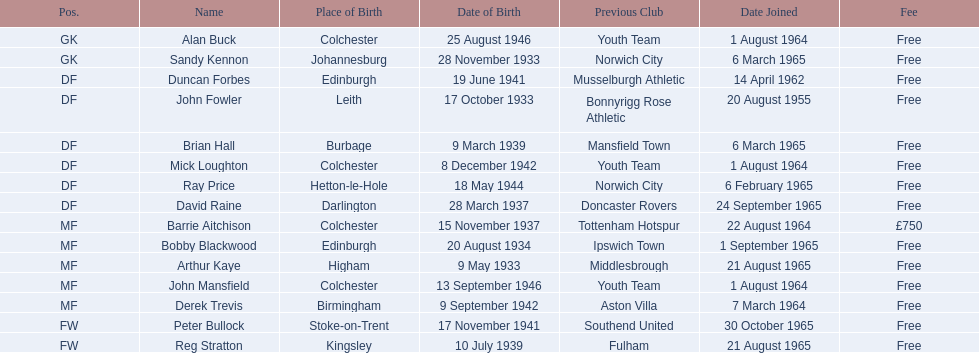What is the date of the lst player that joined? 20 August 1955. 